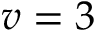<formula> <loc_0><loc_0><loc_500><loc_500>v = 3</formula> 